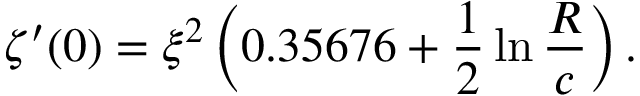Convert formula to latex. <formula><loc_0><loc_0><loc_500><loc_500>\zeta ^ { \prime } ( 0 ) = \xi ^ { 2 } \left ( 0 . 3 5 6 7 6 + \frac { 1 } { 2 } \ln \frac { R } { c } \right ) .</formula> 